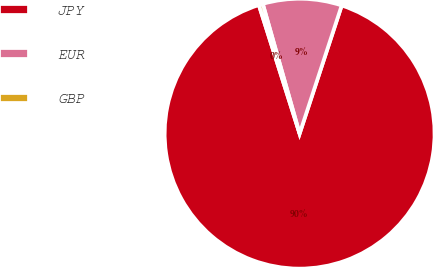<chart> <loc_0><loc_0><loc_500><loc_500><pie_chart><fcel>JPY<fcel>EUR<fcel>GBP<nl><fcel>90.07%<fcel>9.45%<fcel>0.48%<nl></chart> 